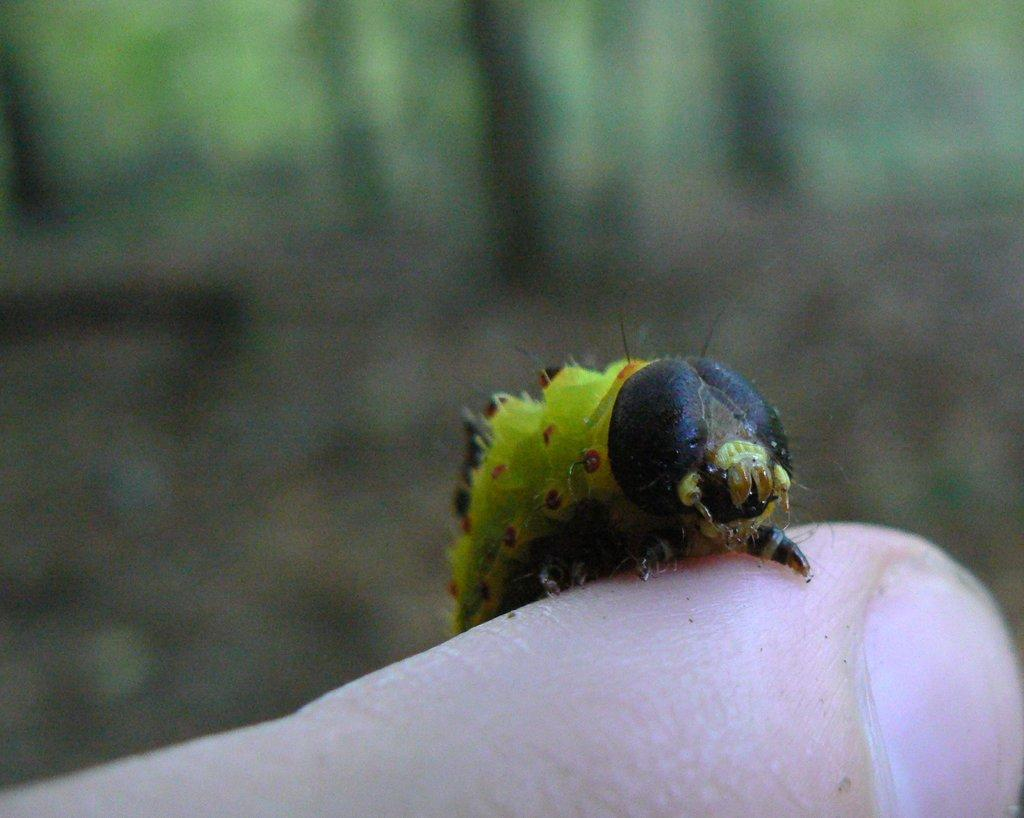What type of creature is in the image? There is a black and green caterpillar in the image. Where is the caterpillar located? The caterpillar is on a finger. Can you describe the background of the image? The background of the image is blurred. What type of fowl can be seen in the image? There is no fowl present in the image; it features a black and green caterpillar on a finger. Is there a ball visible in the image? There is no ball present in the image. 